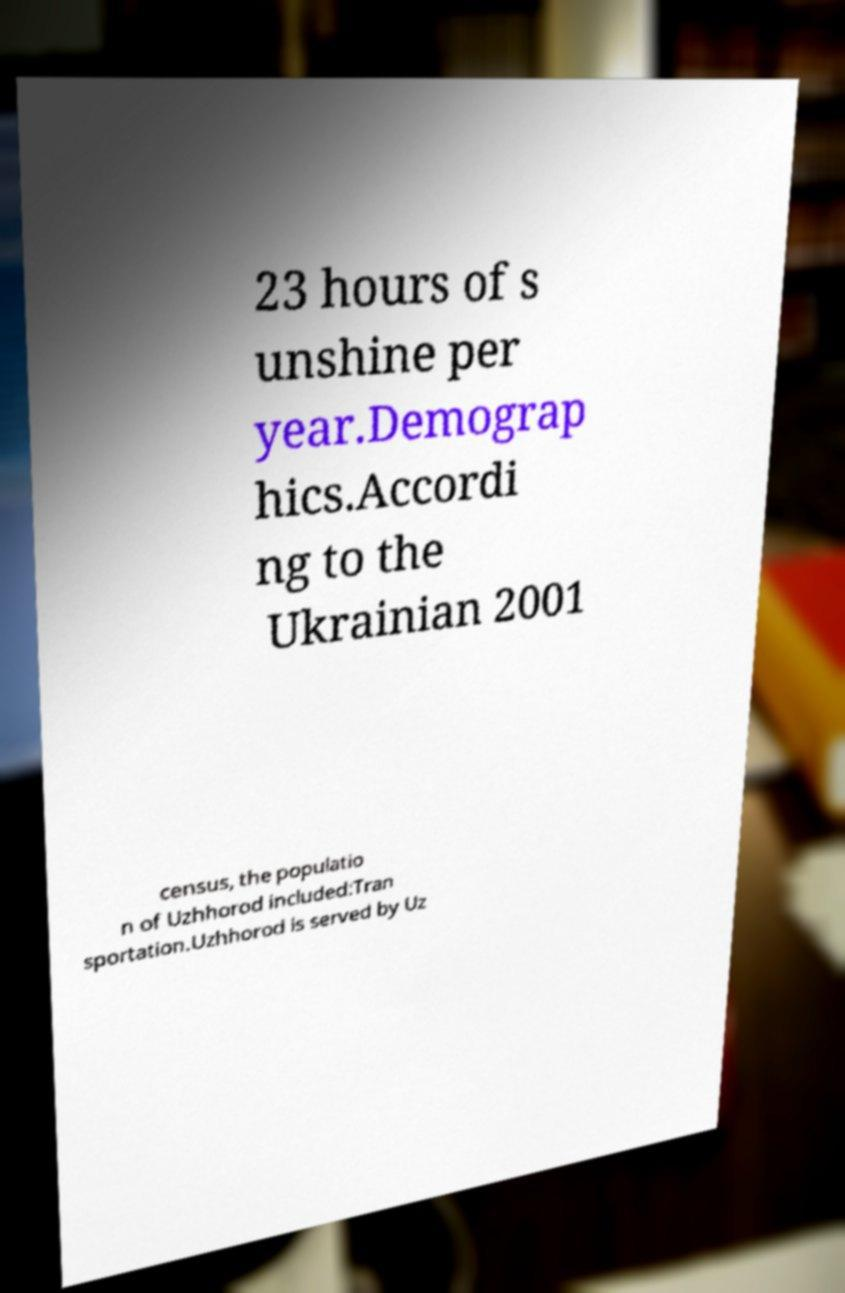I need the written content from this picture converted into text. Can you do that? 23 hours of s unshine per year.Demograp hics.Accordi ng to the Ukrainian 2001 census, the populatio n of Uzhhorod included:Tran sportation.Uzhhorod is served by Uz 